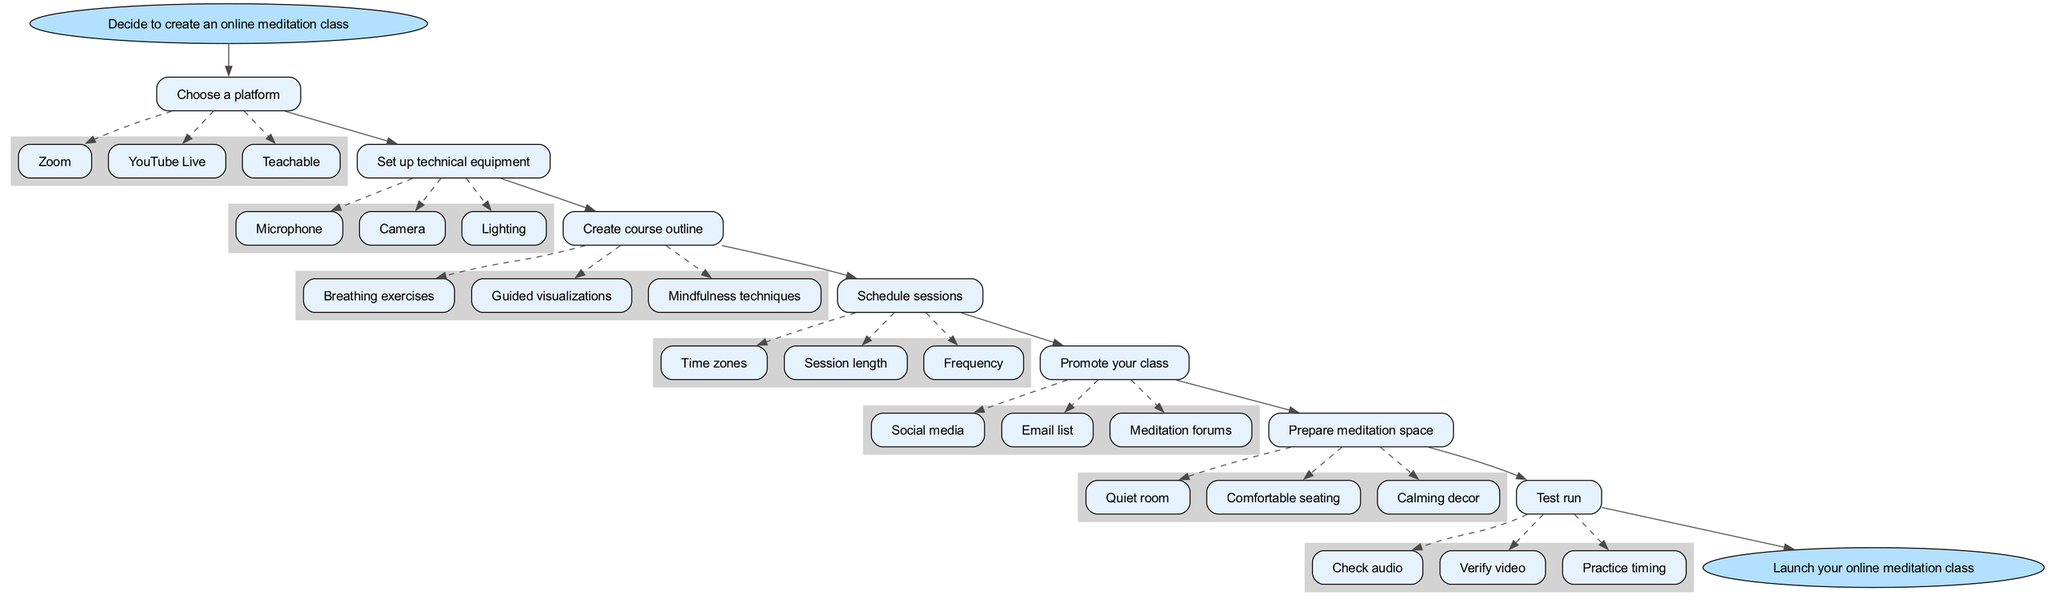What is the first step in setting up an online meditation class? The diagram shows the starting point (the "start" node) which clearly states the first step is to "Decide to create an online meditation class."
Answer: Decide to create an online meditation class How many steps are there in total? Counting the nodes labeled with "Choose a platform," "Set up technical equipment," "Create course outline," "Schedule sessions," "Promote your class," "Prepare meditation space," and "Test run," gives a total of 7 steps.
Answer: 7 What platform options are available for creating an online meditation class? Looking at the node for "Choose a platform," there are three options listed: "Zoom," "YouTube Live," and "Teachable."
Answer: Zoom, YouTube Live, Teachable What is the last step in the flow chart? The diagram ends with a node labeled "Launch your online meditation class," which indicates the final action.
Answer: Launch your online meditation class What are three components that should be included in the course outline? From the "Create course outline" step, the components listed are "Breathing exercises," "Guided visualizations," and "Mindfulness techniques."
Answer: Breathing exercises, Guided visualizations, Mindfulness techniques Which considerations should be taken into account when scheduling sessions? The "Schedule sessions" step lists considerations like "Time zones," "Session length," and "Frequency." All are important to ensure effective scheduling.
Answer: Time zones, Session length, Frequency What is a task associated with the "Test run" step? The "Test run" step has three tasks: "Check audio," "Verify video," and "Practice timing." Any of these can be cited as a task to ensure the setup is functional.
Answer: Check audio How many promotional channels are suggested for promoting the class? There are three channels listed under the "Promote your class" step: "Social media," "Email list," and "Meditation forums." This indicates a total of three channels.
Answer: 3 What is the focus of the "Prepare meditation space" step? This step includes ensuring elements such as "Quiet room," "Comfortable seating," and "Calming decor," which all focus on creating a conducive environment for meditation.
Answer: Quiet room, Comfortable seating, Calming decor 